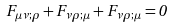Convert formula to latex. <formula><loc_0><loc_0><loc_500><loc_500>F _ { \mu \nu ; \rho } + F _ { \nu \rho ; \mu } + F _ { \nu \rho ; \mu } = 0</formula> 